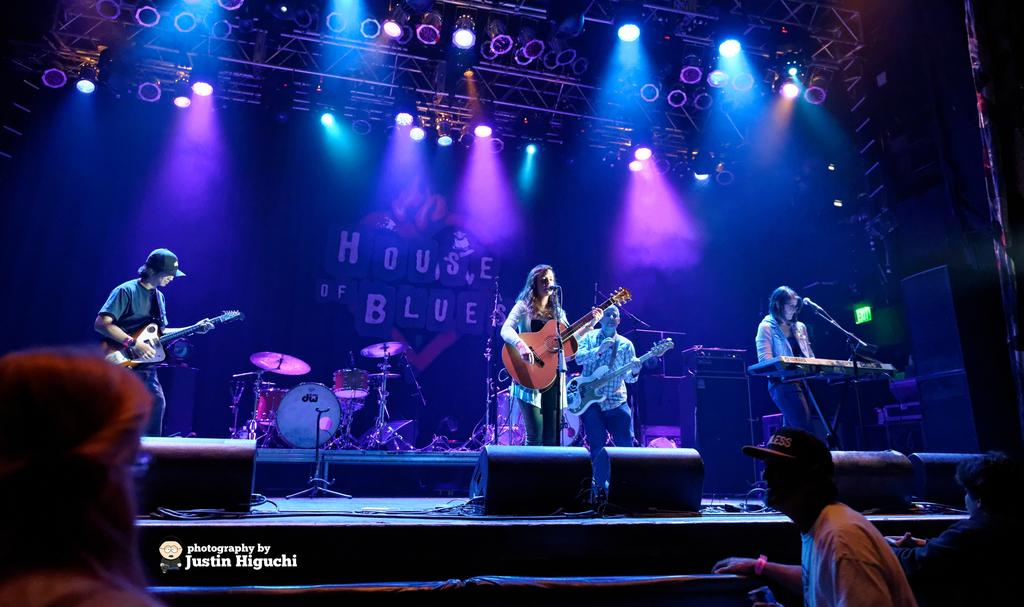What are the people on the stage doing? The people on the stage are performing. What specific activities are the performers engaged in? The performers are playing musical instruments and singing. What can be seen above the stage? There are lights above the stage. How many feet are visible on the stage? There is no mention of feet in the image, as the focus is on the performers and their activities. 